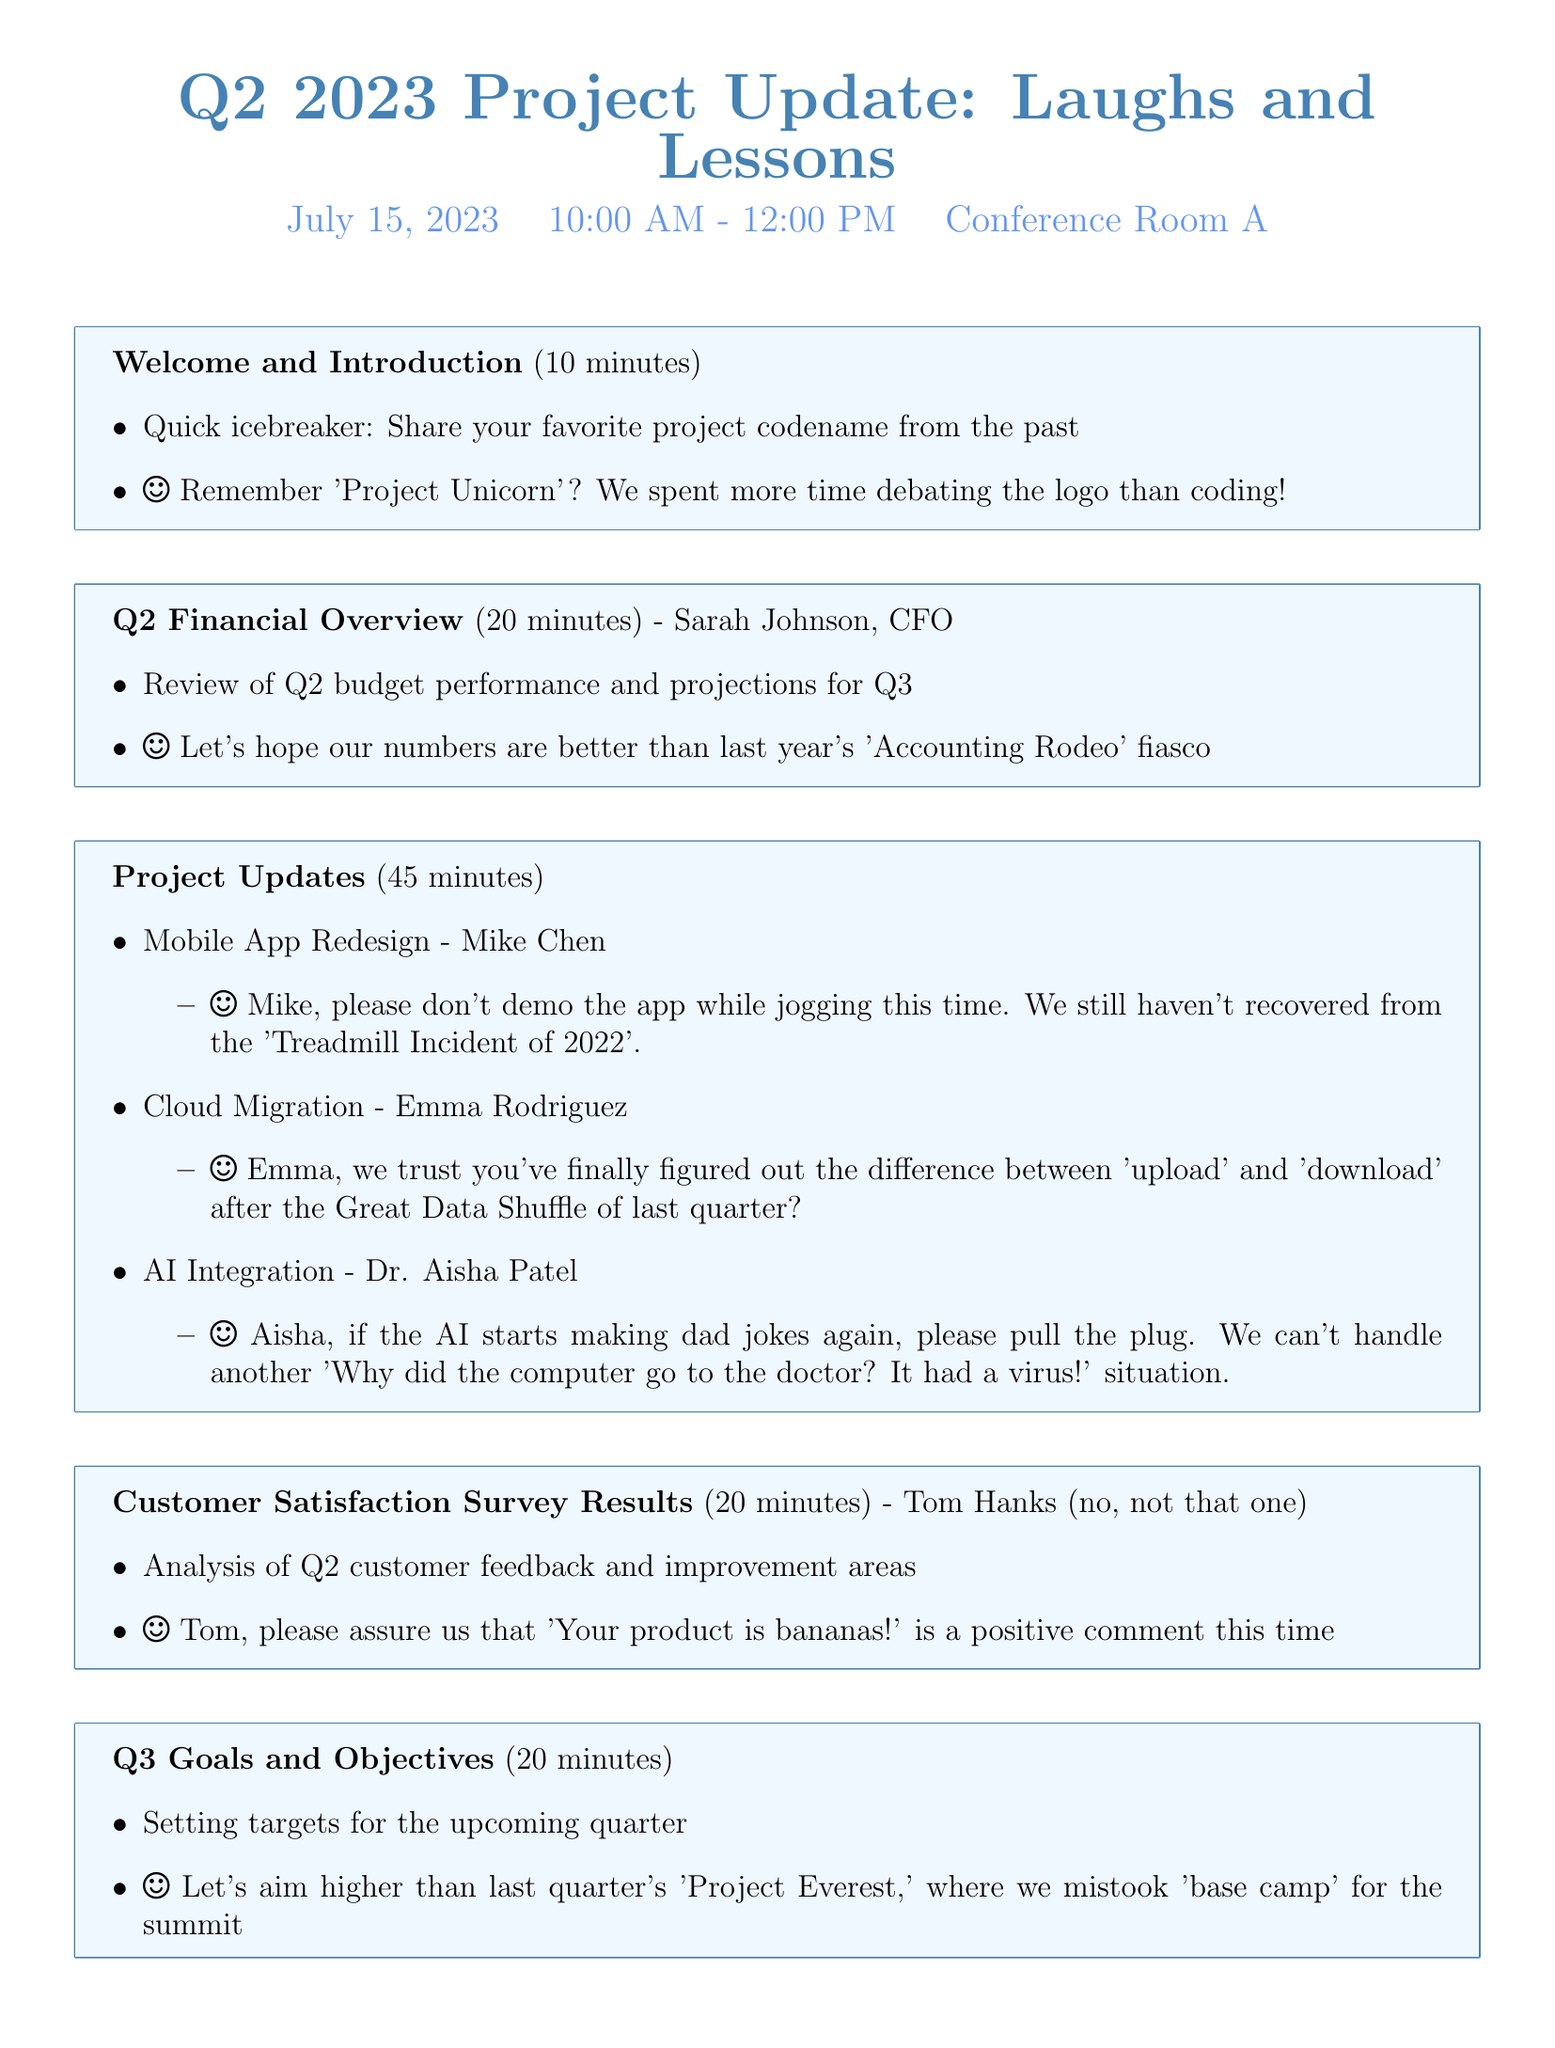What is the meeting title? The meeting title is found at the beginning of the document, providing the main theme for the agenda.
Answer: Q2 2023 Project Update: Laughs and Lessons Who is presenting the Q2 Financial Overview? The presenter's name is mentioned in the agenda section for the financial overview.
Answer: Sarah Johnson, CFO How long is the Open Floor Discussion scheduled for? The duration is listed next to the agenda item for Open Floor Discussion.
Answer: 15 minutes What was the humorous project codename mentioned during the Welcome and Introduction? The codename is included in the details for the icebreaker during the introduction.
Answer: Project Unicorn What is the main anecdote related to the AI Integration project? The anecdote provides context for the project discussion led by Dr. Aisha Patel.
Answer: Aisha, if the AI starts making dad jokes again, please pull the plug What improvement area will be discussed based on customer feedback? The analysis of customer feedback is highlighted in the agenda regarding the Satisfaction Survey Results.
Answer: Improvement areas 